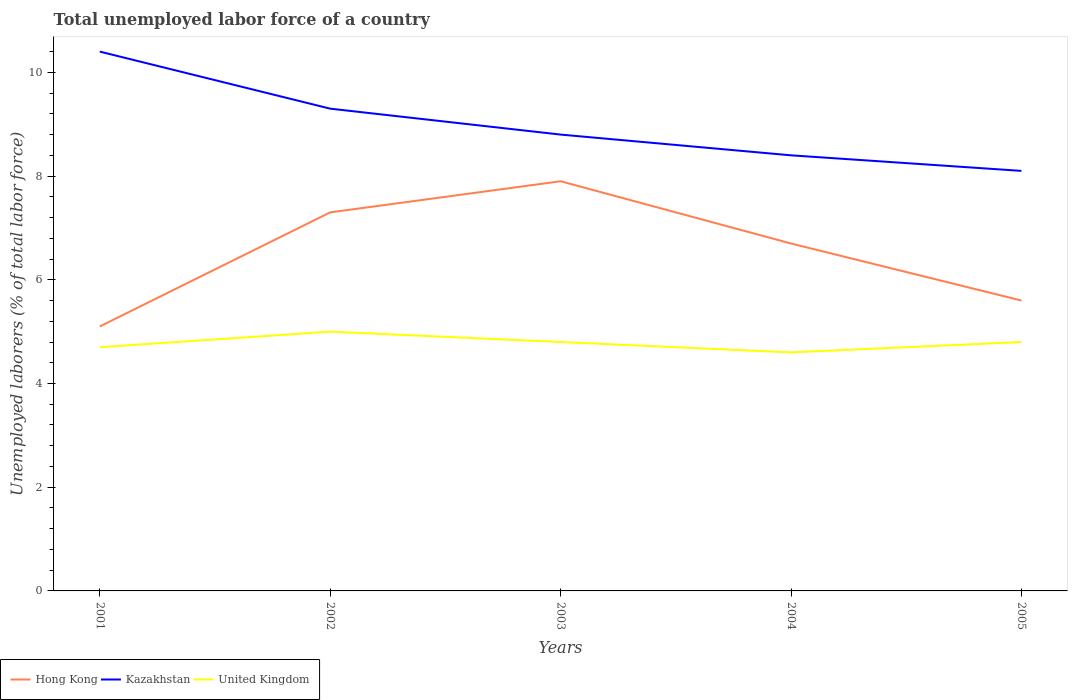Does the line corresponding to Hong Kong intersect with the line corresponding to United Kingdom?
Your answer should be compact. No. Across all years, what is the maximum total unemployed labor force in United Kingdom?
Provide a short and direct response. 4.6. What is the total total unemployed labor force in Kazakhstan in the graph?
Provide a succinct answer. 1.6. What is the difference between the highest and the second highest total unemployed labor force in Kazakhstan?
Your response must be concise. 2.3. What is the difference between the highest and the lowest total unemployed labor force in United Kingdom?
Keep it short and to the point. 3. Is the total unemployed labor force in Hong Kong strictly greater than the total unemployed labor force in Kazakhstan over the years?
Offer a very short reply. Yes. How many years are there in the graph?
Offer a very short reply. 5. Does the graph contain any zero values?
Give a very brief answer. No. Does the graph contain grids?
Your answer should be compact. No. Where does the legend appear in the graph?
Your response must be concise. Bottom left. How are the legend labels stacked?
Your answer should be compact. Horizontal. What is the title of the graph?
Your answer should be very brief. Total unemployed labor force of a country. Does "Macao" appear as one of the legend labels in the graph?
Ensure brevity in your answer.  No. What is the label or title of the X-axis?
Offer a terse response. Years. What is the label or title of the Y-axis?
Your answer should be very brief. Unemployed laborers (% of total labor force). What is the Unemployed laborers (% of total labor force) in Hong Kong in 2001?
Your answer should be compact. 5.1. What is the Unemployed laborers (% of total labor force) in Kazakhstan in 2001?
Provide a short and direct response. 10.4. What is the Unemployed laborers (% of total labor force) in United Kingdom in 2001?
Provide a succinct answer. 4.7. What is the Unemployed laborers (% of total labor force) in Hong Kong in 2002?
Provide a short and direct response. 7.3. What is the Unemployed laborers (% of total labor force) of Kazakhstan in 2002?
Provide a short and direct response. 9.3. What is the Unemployed laborers (% of total labor force) of United Kingdom in 2002?
Your answer should be very brief. 5. What is the Unemployed laborers (% of total labor force) in Hong Kong in 2003?
Your answer should be compact. 7.9. What is the Unemployed laborers (% of total labor force) in Kazakhstan in 2003?
Ensure brevity in your answer.  8.8. What is the Unemployed laborers (% of total labor force) in United Kingdom in 2003?
Offer a very short reply. 4.8. What is the Unemployed laborers (% of total labor force) of Hong Kong in 2004?
Offer a very short reply. 6.7. What is the Unemployed laborers (% of total labor force) in Kazakhstan in 2004?
Provide a short and direct response. 8.4. What is the Unemployed laborers (% of total labor force) in United Kingdom in 2004?
Make the answer very short. 4.6. What is the Unemployed laborers (% of total labor force) of Hong Kong in 2005?
Your response must be concise. 5.6. What is the Unemployed laborers (% of total labor force) in Kazakhstan in 2005?
Keep it short and to the point. 8.1. What is the Unemployed laborers (% of total labor force) of United Kingdom in 2005?
Ensure brevity in your answer.  4.8. Across all years, what is the maximum Unemployed laborers (% of total labor force) of Hong Kong?
Make the answer very short. 7.9. Across all years, what is the maximum Unemployed laborers (% of total labor force) in Kazakhstan?
Your response must be concise. 10.4. Across all years, what is the minimum Unemployed laborers (% of total labor force) in Hong Kong?
Offer a very short reply. 5.1. Across all years, what is the minimum Unemployed laborers (% of total labor force) of Kazakhstan?
Your answer should be compact. 8.1. Across all years, what is the minimum Unemployed laborers (% of total labor force) in United Kingdom?
Offer a very short reply. 4.6. What is the total Unemployed laborers (% of total labor force) in Hong Kong in the graph?
Give a very brief answer. 32.6. What is the total Unemployed laborers (% of total labor force) in Kazakhstan in the graph?
Offer a very short reply. 45. What is the total Unemployed laborers (% of total labor force) in United Kingdom in the graph?
Your answer should be very brief. 23.9. What is the difference between the Unemployed laborers (% of total labor force) of Kazakhstan in 2001 and that in 2002?
Offer a terse response. 1.1. What is the difference between the Unemployed laborers (% of total labor force) in Kazakhstan in 2001 and that in 2003?
Your answer should be very brief. 1.6. What is the difference between the Unemployed laborers (% of total labor force) in Kazakhstan in 2001 and that in 2004?
Ensure brevity in your answer.  2. What is the difference between the Unemployed laborers (% of total labor force) of Hong Kong in 2001 and that in 2005?
Your answer should be very brief. -0.5. What is the difference between the Unemployed laborers (% of total labor force) in Kazakhstan in 2001 and that in 2005?
Provide a succinct answer. 2.3. What is the difference between the Unemployed laborers (% of total labor force) in Hong Kong in 2002 and that in 2004?
Provide a short and direct response. 0.6. What is the difference between the Unemployed laborers (% of total labor force) in Kazakhstan in 2002 and that in 2004?
Provide a short and direct response. 0.9. What is the difference between the Unemployed laborers (% of total labor force) in United Kingdom in 2002 and that in 2004?
Provide a short and direct response. 0.4. What is the difference between the Unemployed laborers (% of total labor force) of Hong Kong in 2002 and that in 2005?
Ensure brevity in your answer.  1.7. What is the difference between the Unemployed laborers (% of total labor force) in United Kingdom in 2003 and that in 2004?
Ensure brevity in your answer.  0.2. What is the difference between the Unemployed laborers (% of total labor force) in Hong Kong in 2003 and that in 2005?
Provide a succinct answer. 2.3. What is the difference between the Unemployed laborers (% of total labor force) of Kazakhstan in 2003 and that in 2005?
Provide a short and direct response. 0.7. What is the difference between the Unemployed laborers (% of total labor force) of United Kingdom in 2003 and that in 2005?
Offer a very short reply. 0. What is the difference between the Unemployed laborers (% of total labor force) in Hong Kong in 2004 and that in 2005?
Provide a succinct answer. 1.1. What is the difference between the Unemployed laborers (% of total labor force) in United Kingdom in 2004 and that in 2005?
Your answer should be compact. -0.2. What is the difference between the Unemployed laborers (% of total labor force) in Hong Kong in 2001 and the Unemployed laborers (% of total labor force) in Kazakhstan in 2002?
Make the answer very short. -4.2. What is the difference between the Unemployed laborers (% of total labor force) of Hong Kong in 2001 and the Unemployed laborers (% of total labor force) of United Kingdom in 2002?
Offer a terse response. 0.1. What is the difference between the Unemployed laborers (% of total labor force) of Hong Kong in 2001 and the Unemployed laborers (% of total labor force) of Kazakhstan in 2005?
Offer a very short reply. -3. What is the difference between the Unemployed laborers (% of total labor force) of Kazakhstan in 2001 and the Unemployed laborers (% of total labor force) of United Kingdom in 2005?
Provide a succinct answer. 5.6. What is the difference between the Unemployed laborers (% of total labor force) in Hong Kong in 2002 and the Unemployed laborers (% of total labor force) in United Kingdom in 2003?
Make the answer very short. 2.5. What is the difference between the Unemployed laborers (% of total labor force) of Kazakhstan in 2002 and the Unemployed laborers (% of total labor force) of United Kingdom in 2004?
Offer a very short reply. 4.7. What is the difference between the Unemployed laborers (% of total labor force) of Hong Kong in 2002 and the Unemployed laborers (% of total labor force) of Kazakhstan in 2005?
Your answer should be compact. -0.8. What is the difference between the Unemployed laborers (% of total labor force) of Kazakhstan in 2002 and the Unemployed laborers (% of total labor force) of United Kingdom in 2005?
Offer a very short reply. 4.5. What is the difference between the Unemployed laborers (% of total labor force) in Hong Kong in 2003 and the Unemployed laborers (% of total labor force) in Kazakhstan in 2004?
Provide a short and direct response. -0.5. What is the difference between the Unemployed laborers (% of total labor force) in Hong Kong in 2003 and the Unemployed laborers (% of total labor force) in United Kingdom in 2004?
Make the answer very short. 3.3. What is the difference between the Unemployed laborers (% of total labor force) of Hong Kong in 2003 and the Unemployed laborers (% of total labor force) of Kazakhstan in 2005?
Your response must be concise. -0.2. What is the difference between the Unemployed laborers (% of total labor force) in Kazakhstan in 2003 and the Unemployed laborers (% of total labor force) in United Kingdom in 2005?
Your response must be concise. 4. What is the difference between the Unemployed laborers (% of total labor force) of Hong Kong in 2004 and the Unemployed laborers (% of total labor force) of United Kingdom in 2005?
Provide a short and direct response. 1.9. What is the difference between the Unemployed laborers (% of total labor force) of Kazakhstan in 2004 and the Unemployed laborers (% of total labor force) of United Kingdom in 2005?
Your response must be concise. 3.6. What is the average Unemployed laborers (% of total labor force) in Hong Kong per year?
Give a very brief answer. 6.52. What is the average Unemployed laborers (% of total labor force) in United Kingdom per year?
Your answer should be very brief. 4.78. In the year 2001, what is the difference between the Unemployed laborers (% of total labor force) of Hong Kong and Unemployed laborers (% of total labor force) of Kazakhstan?
Your response must be concise. -5.3. In the year 2001, what is the difference between the Unemployed laborers (% of total labor force) in Hong Kong and Unemployed laborers (% of total labor force) in United Kingdom?
Your answer should be very brief. 0.4. In the year 2001, what is the difference between the Unemployed laborers (% of total labor force) of Kazakhstan and Unemployed laborers (% of total labor force) of United Kingdom?
Your response must be concise. 5.7. In the year 2002, what is the difference between the Unemployed laborers (% of total labor force) in Hong Kong and Unemployed laborers (% of total labor force) in Kazakhstan?
Your response must be concise. -2. In the year 2002, what is the difference between the Unemployed laborers (% of total labor force) in Hong Kong and Unemployed laborers (% of total labor force) in United Kingdom?
Your response must be concise. 2.3. In the year 2002, what is the difference between the Unemployed laborers (% of total labor force) in Kazakhstan and Unemployed laborers (% of total labor force) in United Kingdom?
Your answer should be very brief. 4.3. In the year 2003, what is the difference between the Unemployed laborers (% of total labor force) in Hong Kong and Unemployed laborers (% of total labor force) in United Kingdom?
Your answer should be compact. 3.1. In the year 2003, what is the difference between the Unemployed laborers (% of total labor force) of Kazakhstan and Unemployed laborers (% of total labor force) of United Kingdom?
Your answer should be very brief. 4. In the year 2004, what is the difference between the Unemployed laborers (% of total labor force) in Hong Kong and Unemployed laborers (% of total labor force) in Kazakhstan?
Provide a short and direct response. -1.7. In the year 2004, what is the difference between the Unemployed laborers (% of total labor force) in Kazakhstan and Unemployed laborers (% of total labor force) in United Kingdom?
Give a very brief answer. 3.8. In the year 2005, what is the difference between the Unemployed laborers (% of total labor force) in Hong Kong and Unemployed laborers (% of total labor force) in United Kingdom?
Your response must be concise. 0.8. What is the ratio of the Unemployed laborers (% of total labor force) in Hong Kong in 2001 to that in 2002?
Provide a succinct answer. 0.7. What is the ratio of the Unemployed laborers (% of total labor force) in Kazakhstan in 2001 to that in 2002?
Provide a succinct answer. 1.12. What is the ratio of the Unemployed laborers (% of total labor force) in United Kingdom in 2001 to that in 2002?
Offer a very short reply. 0.94. What is the ratio of the Unemployed laborers (% of total labor force) in Hong Kong in 2001 to that in 2003?
Give a very brief answer. 0.65. What is the ratio of the Unemployed laborers (% of total labor force) of Kazakhstan in 2001 to that in 2003?
Ensure brevity in your answer.  1.18. What is the ratio of the Unemployed laborers (% of total labor force) of United Kingdom in 2001 to that in 2003?
Make the answer very short. 0.98. What is the ratio of the Unemployed laborers (% of total labor force) of Hong Kong in 2001 to that in 2004?
Your answer should be compact. 0.76. What is the ratio of the Unemployed laborers (% of total labor force) in Kazakhstan in 2001 to that in 2004?
Provide a succinct answer. 1.24. What is the ratio of the Unemployed laborers (% of total labor force) of United Kingdom in 2001 to that in 2004?
Make the answer very short. 1.02. What is the ratio of the Unemployed laborers (% of total labor force) of Hong Kong in 2001 to that in 2005?
Your response must be concise. 0.91. What is the ratio of the Unemployed laborers (% of total labor force) in Kazakhstan in 2001 to that in 2005?
Your answer should be compact. 1.28. What is the ratio of the Unemployed laborers (% of total labor force) in United Kingdom in 2001 to that in 2005?
Ensure brevity in your answer.  0.98. What is the ratio of the Unemployed laborers (% of total labor force) of Hong Kong in 2002 to that in 2003?
Keep it short and to the point. 0.92. What is the ratio of the Unemployed laborers (% of total labor force) in Kazakhstan in 2002 to that in 2003?
Your response must be concise. 1.06. What is the ratio of the Unemployed laborers (% of total labor force) of United Kingdom in 2002 to that in 2003?
Your answer should be compact. 1.04. What is the ratio of the Unemployed laborers (% of total labor force) in Hong Kong in 2002 to that in 2004?
Give a very brief answer. 1.09. What is the ratio of the Unemployed laborers (% of total labor force) in Kazakhstan in 2002 to that in 2004?
Make the answer very short. 1.11. What is the ratio of the Unemployed laborers (% of total labor force) of United Kingdom in 2002 to that in 2004?
Your response must be concise. 1.09. What is the ratio of the Unemployed laborers (% of total labor force) in Hong Kong in 2002 to that in 2005?
Give a very brief answer. 1.3. What is the ratio of the Unemployed laborers (% of total labor force) in Kazakhstan in 2002 to that in 2005?
Your answer should be compact. 1.15. What is the ratio of the Unemployed laborers (% of total labor force) in United Kingdom in 2002 to that in 2005?
Keep it short and to the point. 1.04. What is the ratio of the Unemployed laborers (% of total labor force) in Hong Kong in 2003 to that in 2004?
Provide a short and direct response. 1.18. What is the ratio of the Unemployed laborers (% of total labor force) in Kazakhstan in 2003 to that in 2004?
Provide a succinct answer. 1.05. What is the ratio of the Unemployed laborers (% of total labor force) of United Kingdom in 2003 to that in 2004?
Provide a short and direct response. 1.04. What is the ratio of the Unemployed laborers (% of total labor force) in Hong Kong in 2003 to that in 2005?
Give a very brief answer. 1.41. What is the ratio of the Unemployed laborers (% of total labor force) of Kazakhstan in 2003 to that in 2005?
Your answer should be compact. 1.09. What is the ratio of the Unemployed laborers (% of total labor force) of Hong Kong in 2004 to that in 2005?
Provide a succinct answer. 1.2. What is the ratio of the Unemployed laborers (% of total labor force) of United Kingdom in 2004 to that in 2005?
Your response must be concise. 0.96. What is the difference between the highest and the second highest Unemployed laborers (% of total labor force) of Kazakhstan?
Make the answer very short. 1.1. What is the difference between the highest and the lowest Unemployed laborers (% of total labor force) of United Kingdom?
Your response must be concise. 0.4. 